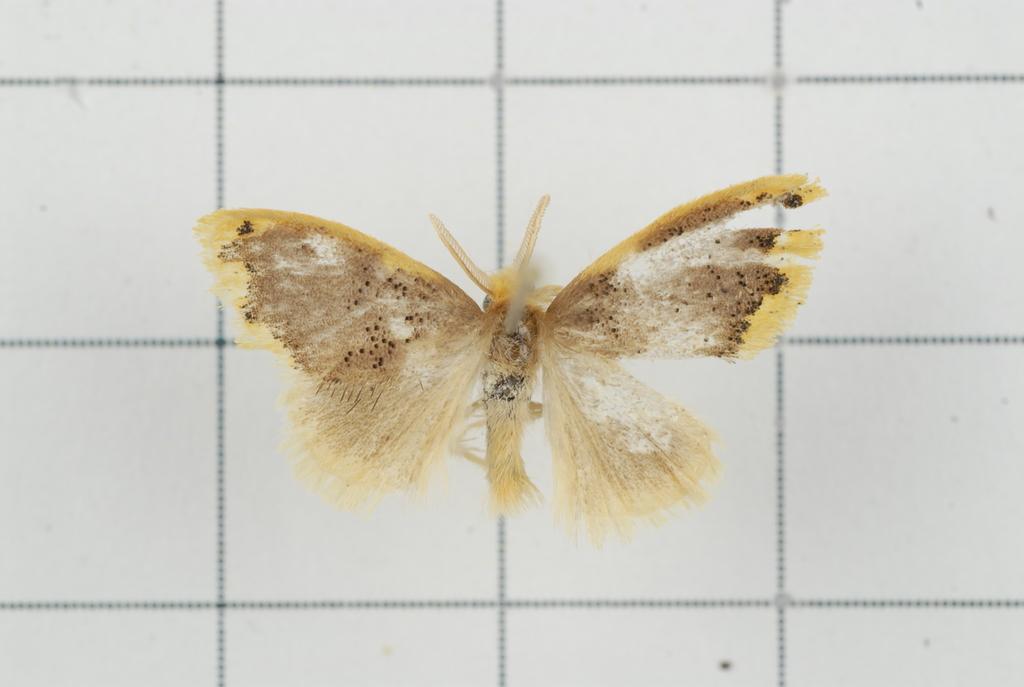Could you give a brief overview of what you see in this image? In the image there is a yellow color moth standing on tiles floor. 